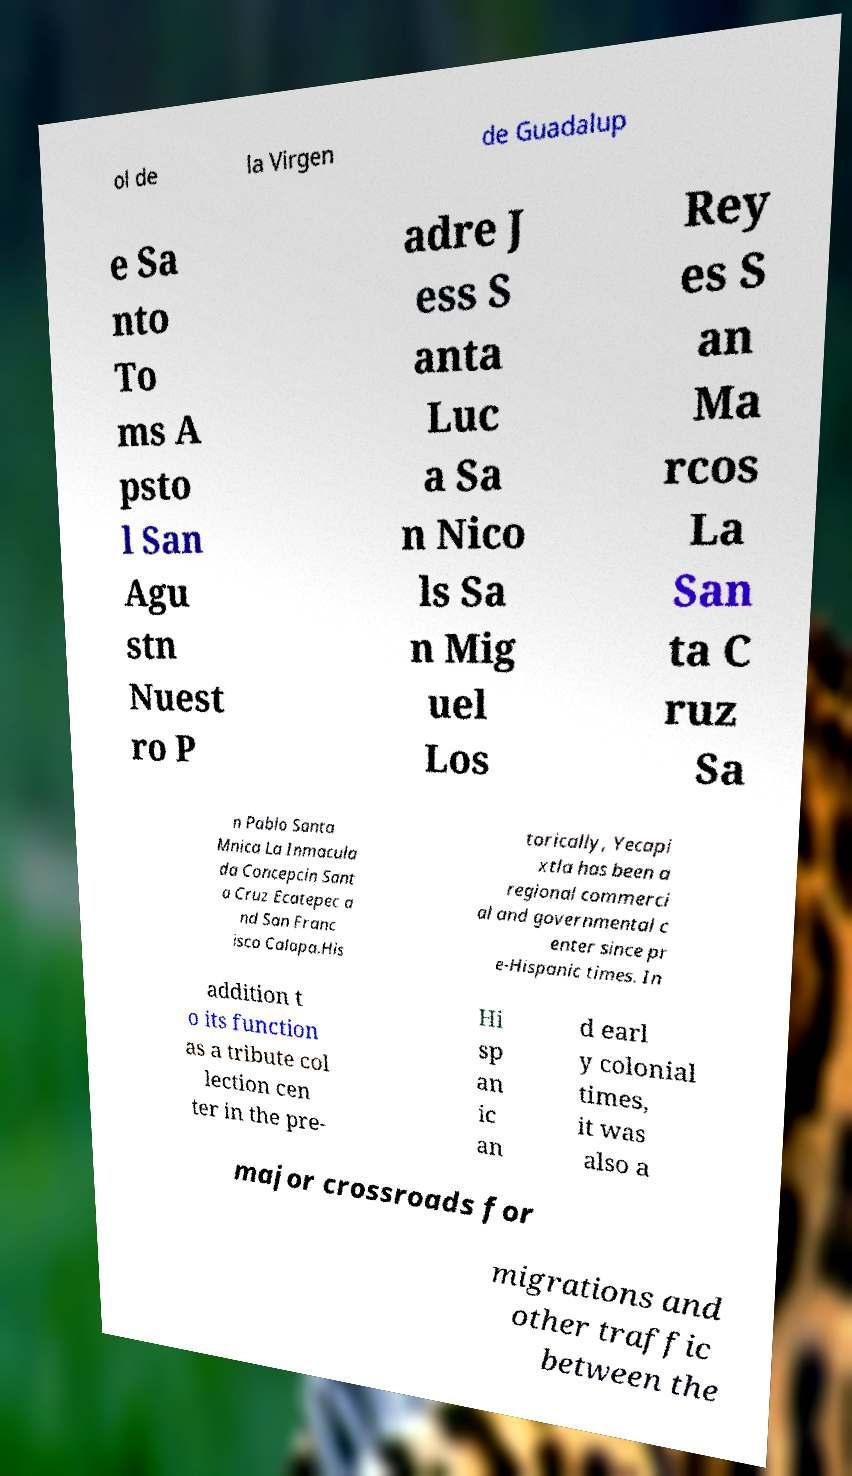Please read and relay the text visible in this image. What does it say? ol de la Virgen de Guadalup e Sa nto To ms A psto l San Agu stn Nuest ro P adre J ess S anta Luc a Sa n Nico ls Sa n Mig uel Los Rey es S an Ma rcos La San ta C ruz Sa n Pablo Santa Mnica La Inmacula da Concepcin Sant a Cruz Ecatepec a nd San Franc isco Calapa.His torically, Yecapi xtla has been a regional commerci al and governmental c enter since pr e-Hispanic times. In addition t o its function as a tribute col lection cen ter in the pre- Hi sp an ic an d earl y colonial times, it was also a major crossroads for migrations and other traffic between the 